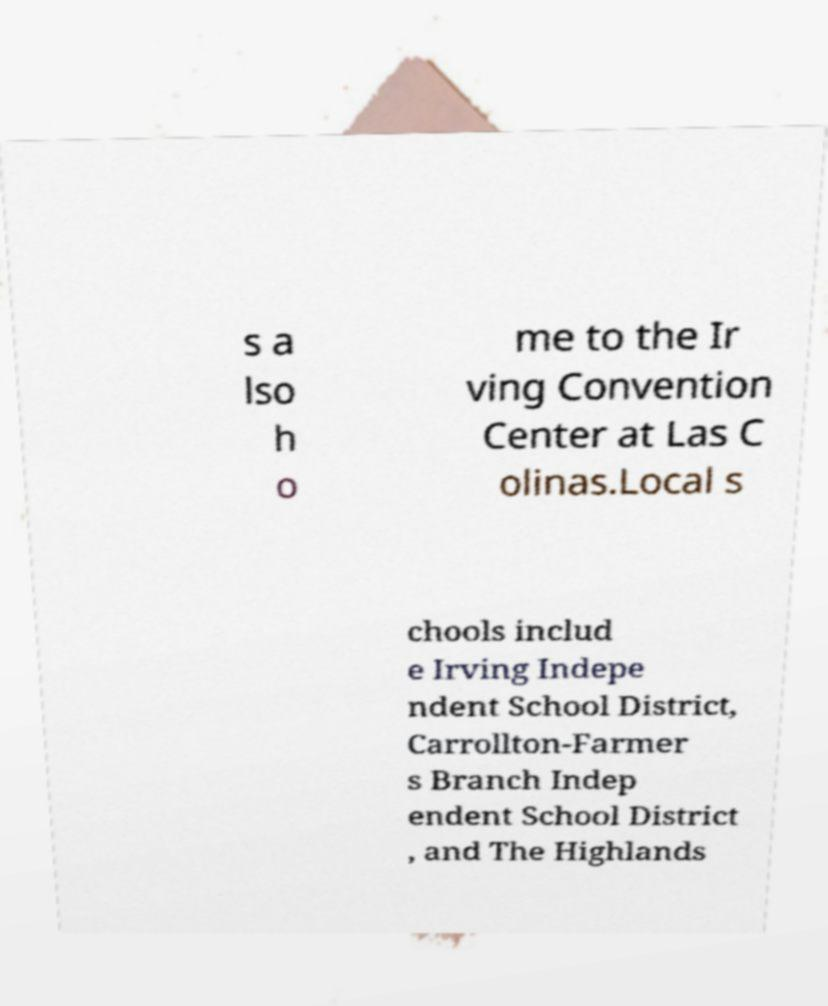Please identify and transcribe the text found in this image. s a lso h o me to the Ir ving Convention Center at Las C olinas.Local s chools includ e Irving Indepe ndent School District, Carrollton-Farmer s Branch Indep endent School District , and The Highlands 